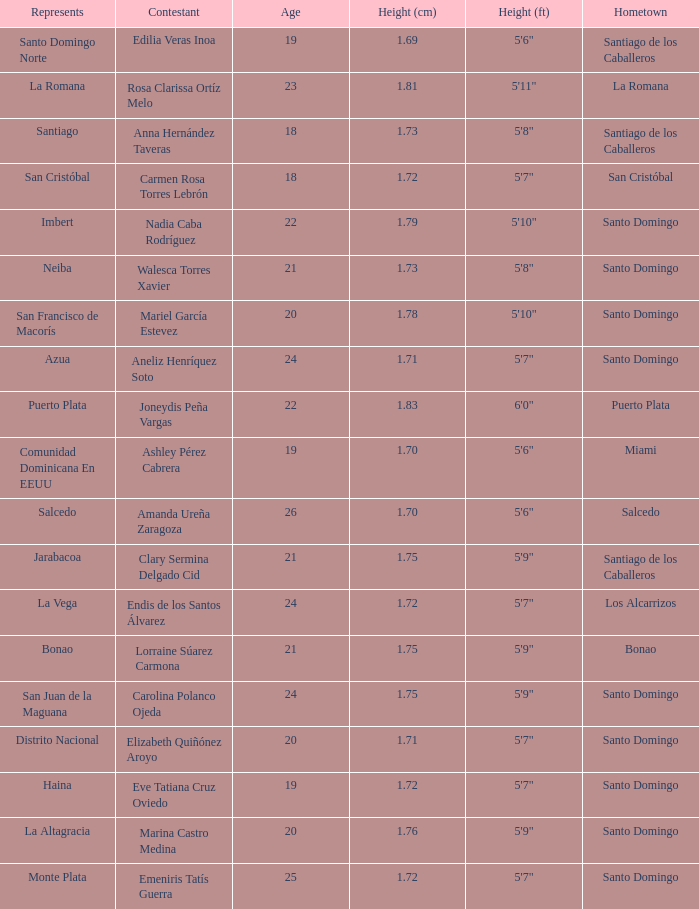Name the most age 26.0. 